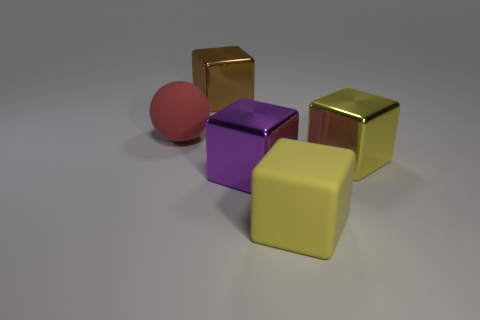Subtract all yellow balls. Subtract all yellow blocks. How many balls are left? 1 Add 3 big red balls. How many objects exist? 8 Subtract all blocks. How many objects are left? 1 Subtract 1 brown cubes. How many objects are left? 4 Subtract all big red objects. Subtract all yellow rubber objects. How many objects are left? 3 Add 2 large red rubber things. How many large red rubber things are left? 3 Add 1 rubber spheres. How many rubber spheres exist? 2 